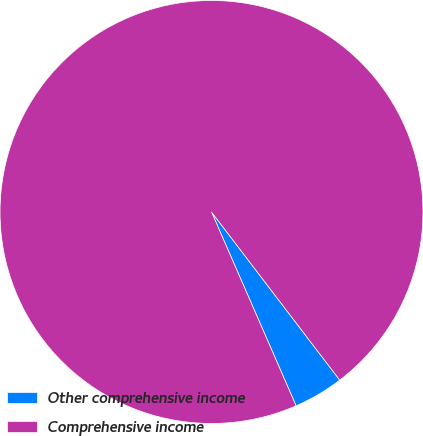Convert chart to OTSL. <chart><loc_0><loc_0><loc_500><loc_500><pie_chart><fcel>Other comprehensive income<fcel>Comprehensive income<nl><fcel>3.82%<fcel>96.18%<nl></chart> 